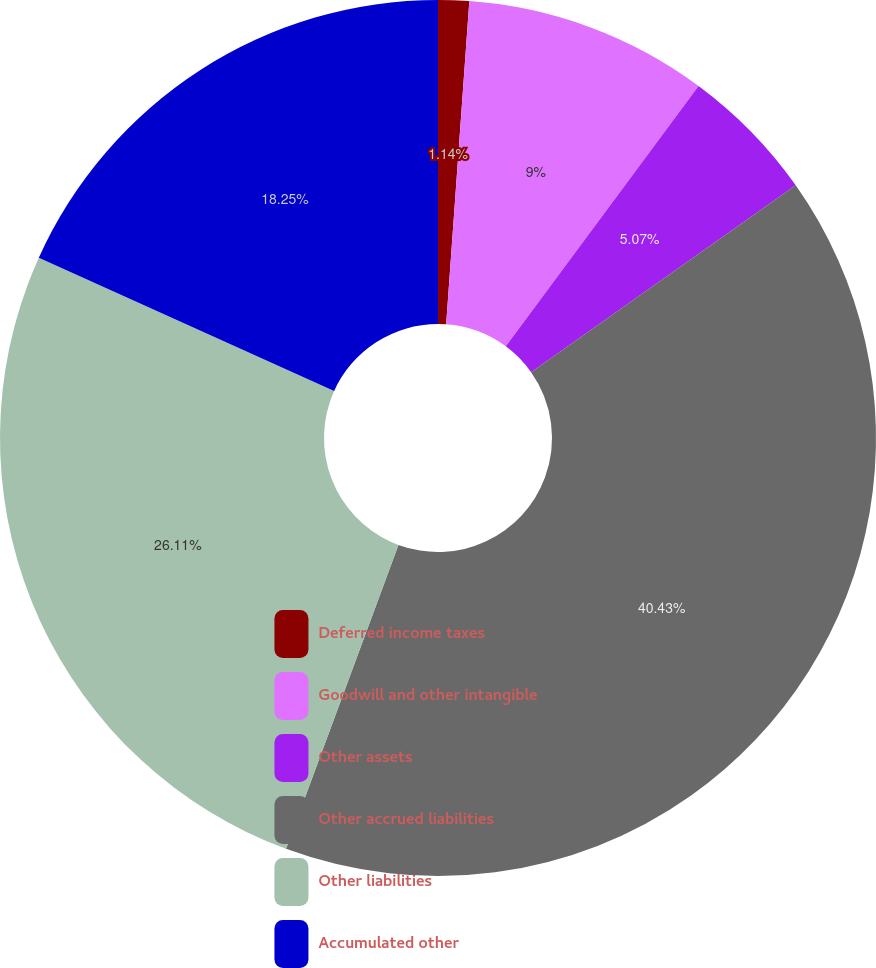Convert chart. <chart><loc_0><loc_0><loc_500><loc_500><pie_chart><fcel>Deferred income taxes<fcel>Goodwill and other intangible<fcel>Other assets<fcel>Other accrued liabilities<fcel>Other liabilities<fcel>Accumulated other<nl><fcel>1.14%<fcel>9.0%<fcel>5.07%<fcel>40.43%<fcel>26.11%<fcel>18.25%<nl></chart> 